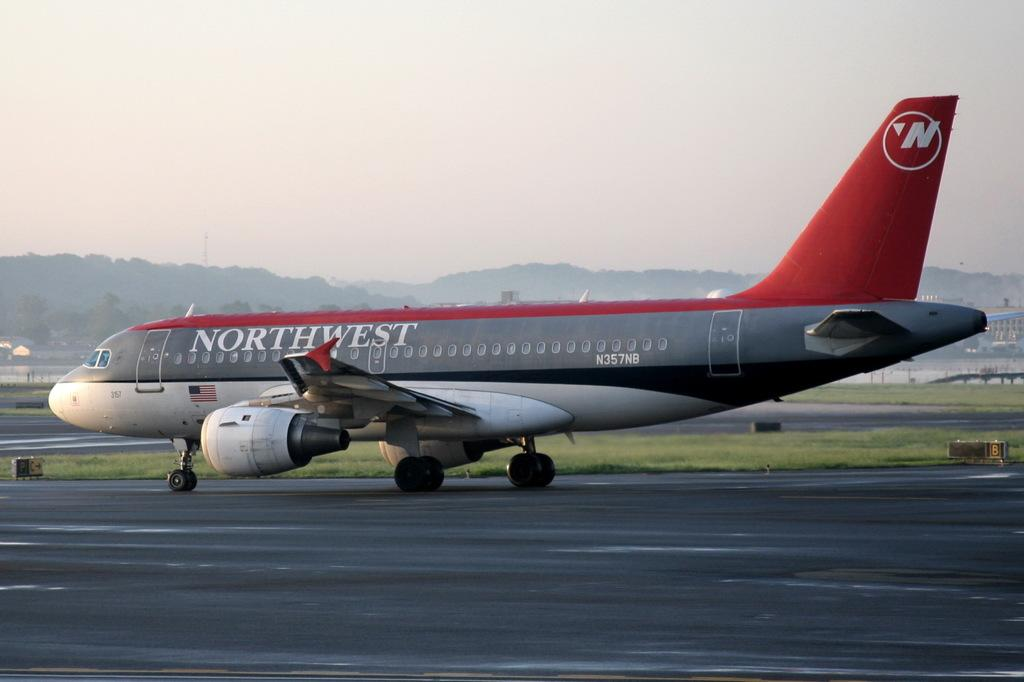<image>
Present a compact description of the photo's key features. A Northwest airlines plane taxes on a runway 